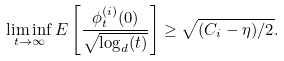<formula> <loc_0><loc_0><loc_500><loc_500>\liminf _ { t \to \infty } E \left [ \frac { \phi _ { t } ^ { ( i ) } ( 0 ) } { \sqrt { \log _ { d } ( t ) } } \right ] \geq \sqrt { ( C _ { i } - \eta ) / 2 } .</formula> 